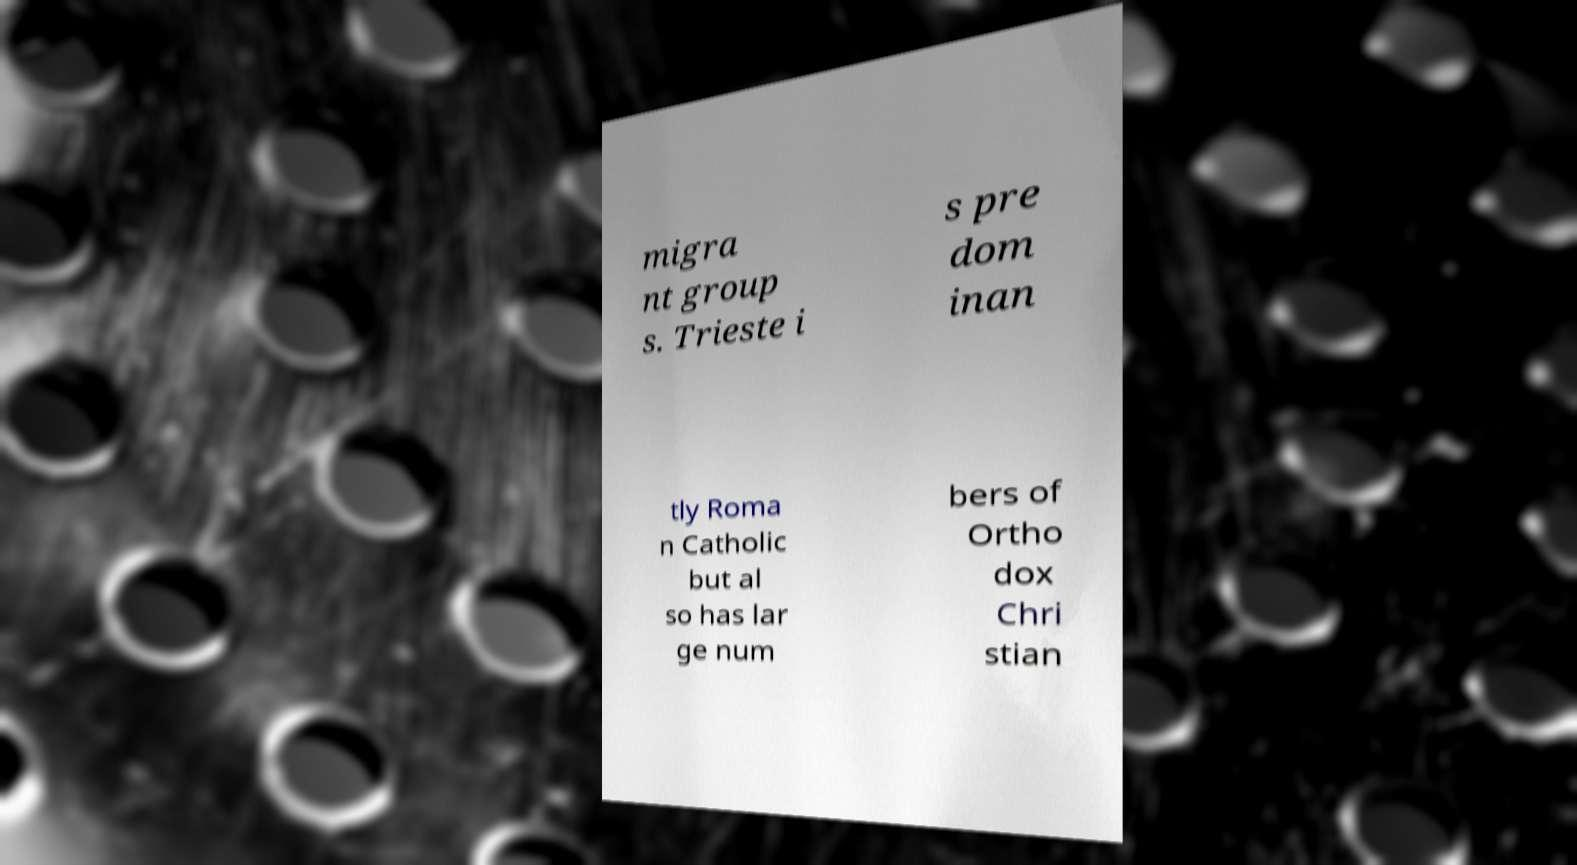There's text embedded in this image that I need extracted. Can you transcribe it verbatim? migra nt group s. Trieste i s pre dom inan tly Roma n Catholic but al so has lar ge num bers of Ortho dox Chri stian 